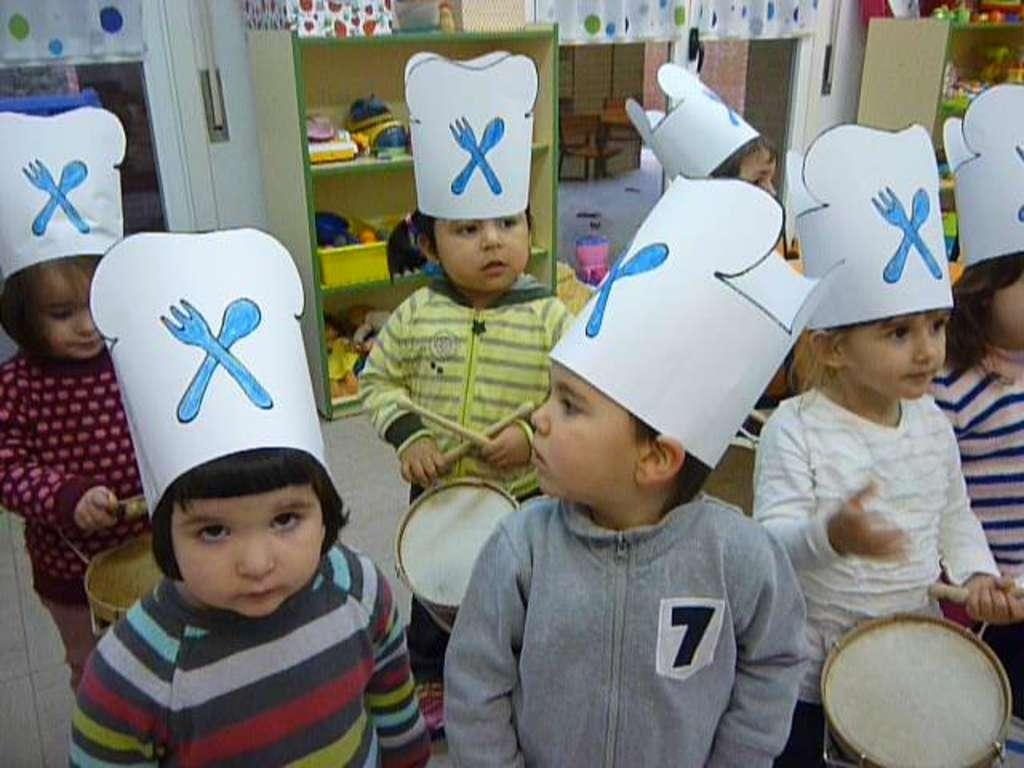What can be seen in the image? There are people standing in the image. What are the people wearing on their heads? The people are wearing hats. What can be seen in the background of the image? There are shelves visible in the background, and there is a white-colored wall. What type of iron is being used to cook the flesh in the image? There is no iron or flesh present in the image; it features people standing and wearing hats, with shelves and a white-colored wall in the background. 